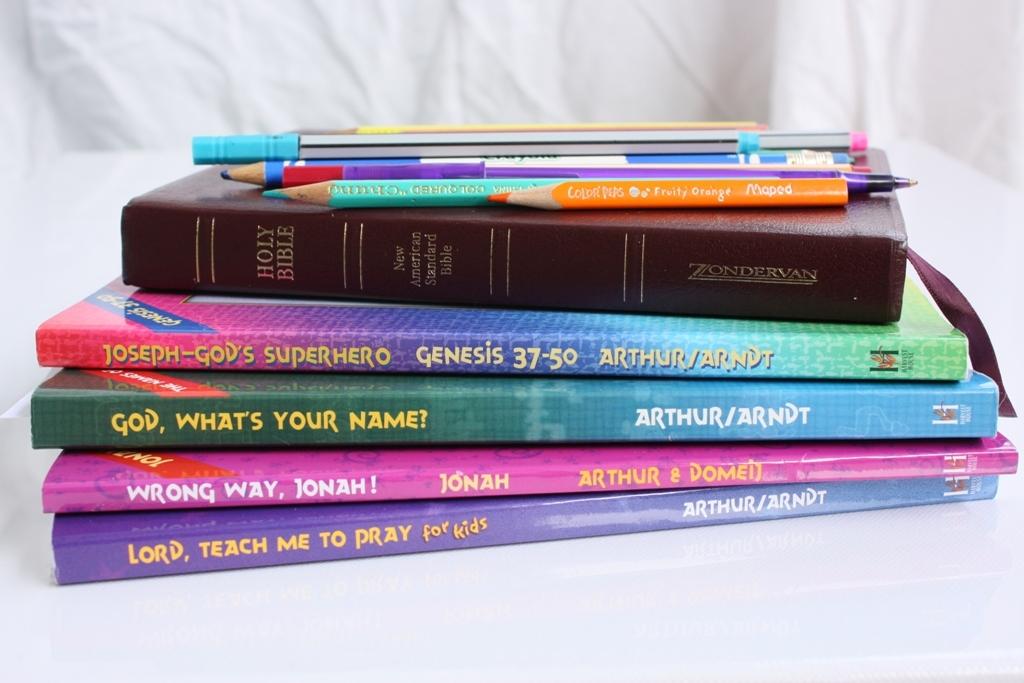Who are the authors of the bottom book?
Make the answer very short. Arthur/arndt. What is the name of the second to last book?
Offer a terse response. Wrong way, jonah!. 